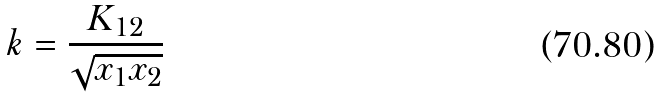Convert formula to latex. <formula><loc_0><loc_0><loc_500><loc_500>k = \frac { K _ { 1 2 } } { \sqrt { x _ { 1 } x _ { 2 } } }</formula> 